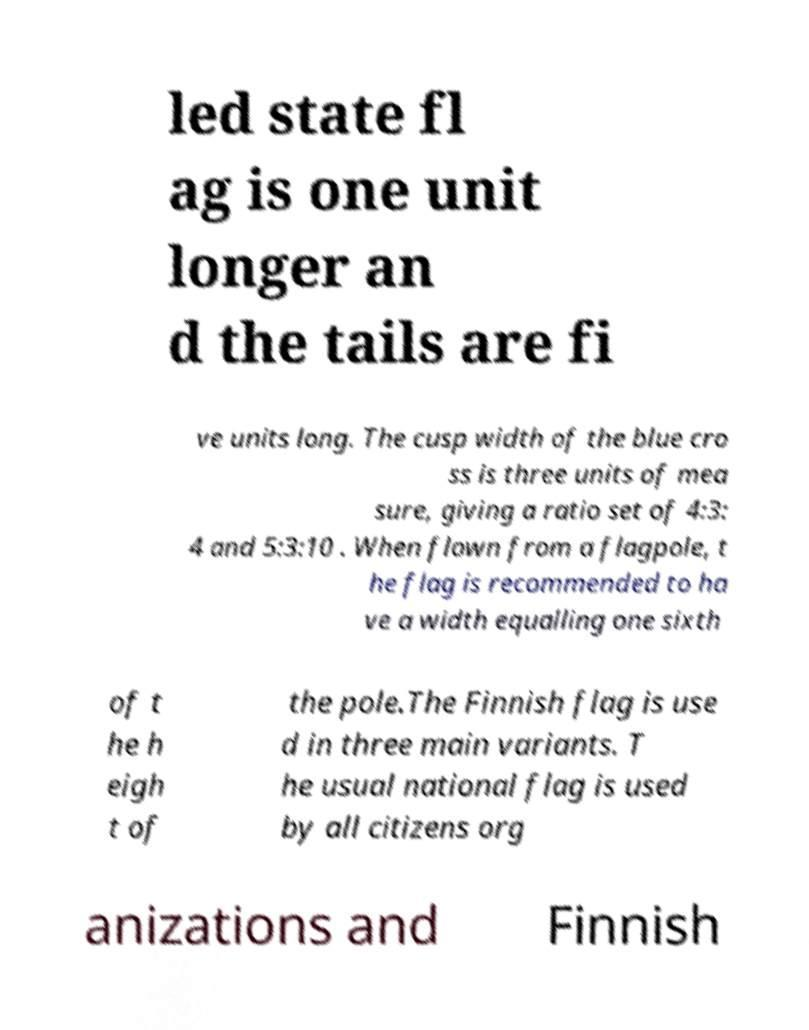Please identify and transcribe the text found in this image. led state fl ag is one unit longer an d the tails are fi ve units long. The cusp width of the blue cro ss is three units of mea sure, giving a ratio set of 4:3: 4 and 5:3:10 . When flown from a flagpole, t he flag is recommended to ha ve a width equalling one sixth of t he h eigh t of the pole.The Finnish flag is use d in three main variants. T he usual national flag is used by all citizens org anizations and Finnish 